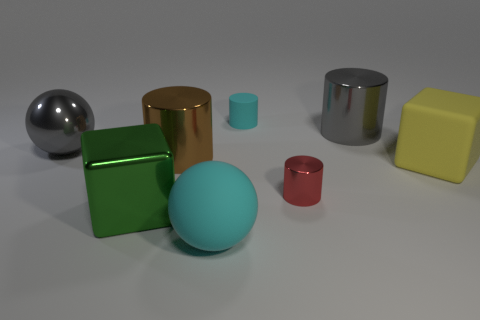Are there more yellow blocks that are on the left side of the metal cube than yellow matte objects that are in front of the cyan matte ball?
Your response must be concise. No. What size is the brown thing?
Ensure brevity in your answer.  Large. Are there any big metal things that have the same shape as the large yellow matte thing?
Offer a terse response. Yes. There is a large yellow object; is its shape the same as the cyan object behind the big yellow matte block?
Offer a terse response. No. How big is the matte thing that is both on the left side of the red metallic cylinder and on the right side of the cyan ball?
Keep it short and to the point. Small. How many cylinders are there?
Ensure brevity in your answer.  4. What material is the brown thing that is the same size as the matte ball?
Provide a short and direct response. Metal. Is there a yellow cube of the same size as the cyan ball?
Offer a very short reply. Yes. There is a metal cylinder to the right of the tiny red object; is its color the same as the block on the left side of the big cyan thing?
Provide a succinct answer. No. How many shiny objects are either green blocks or big gray cylinders?
Keep it short and to the point. 2. 